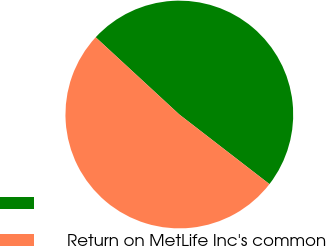Convert chart. <chart><loc_0><loc_0><loc_500><loc_500><pie_chart><ecel><fcel>Return on MetLife Inc's common<nl><fcel>48.6%<fcel>51.4%<nl></chart> 